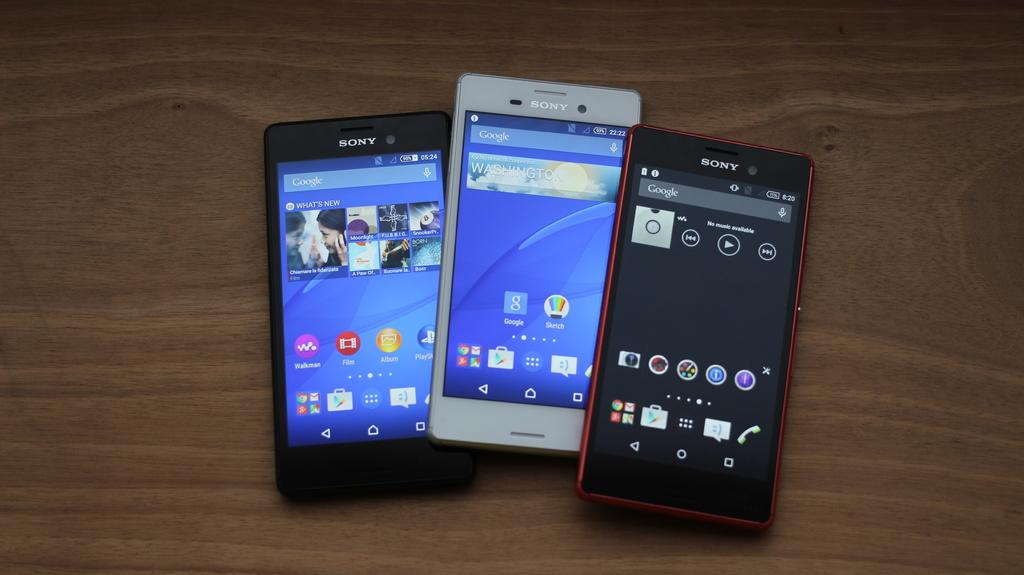Provide a one-sentence caption for the provided image. A group of 3 phones all made by the brand Sony. 